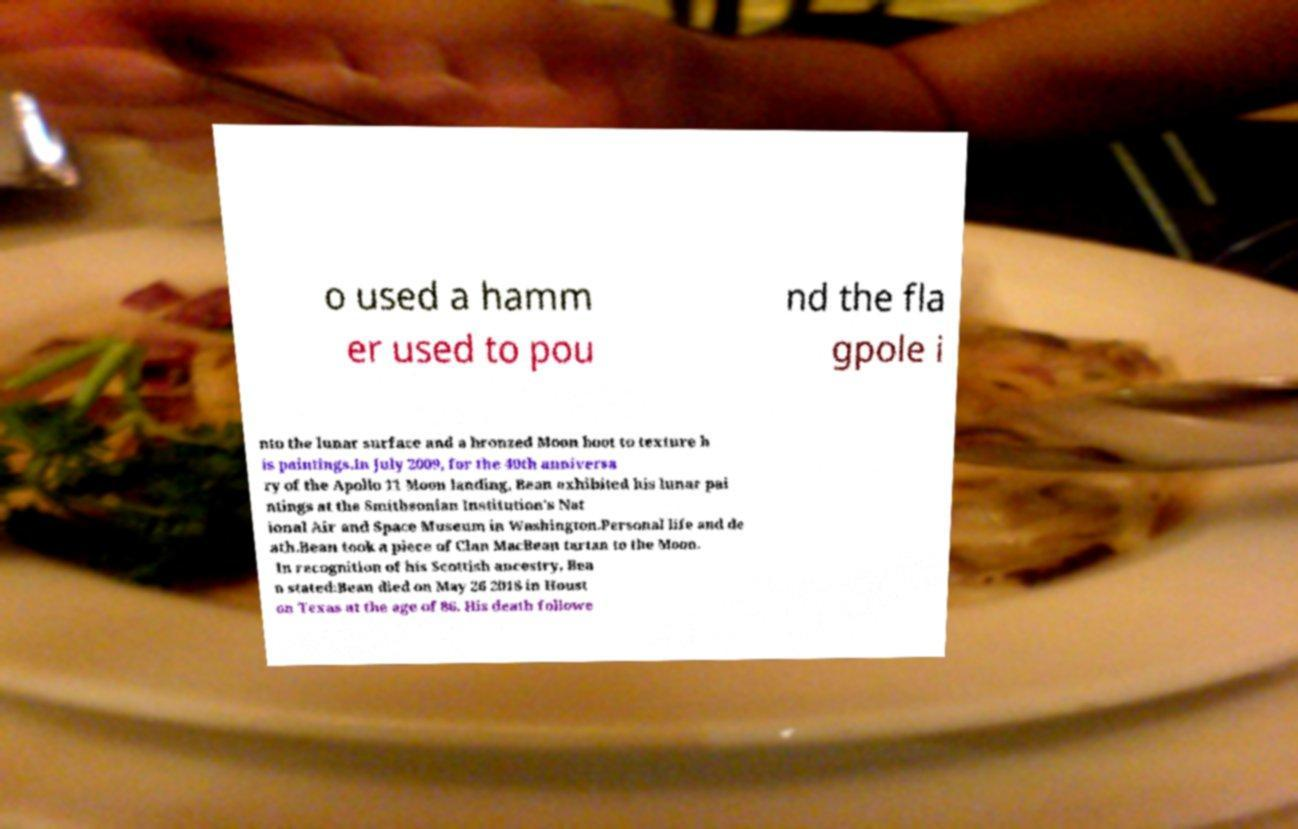Can you read and provide the text displayed in the image?This photo seems to have some interesting text. Can you extract and type it out for me? o used a hamm er used to pou nd the fla gpole i nto the lunar surface and a bronzed Moon boot to texture h is paintings.In July 2009, for the 40th anniversa ry of the Apollo 11 Moon landing, Bean exhibited his lunar pai ntings at the Smithsonian Institution's Nat ional Air and Space Museum in Washington.Personal life and de ath.Bean took a piece of Clan MacBean tartan to the Moon. In recognition of his Scottish ancestry, Bea n stated:Bean died on May 26 2018 in Houst on Texas at the age of 86. His death followe 